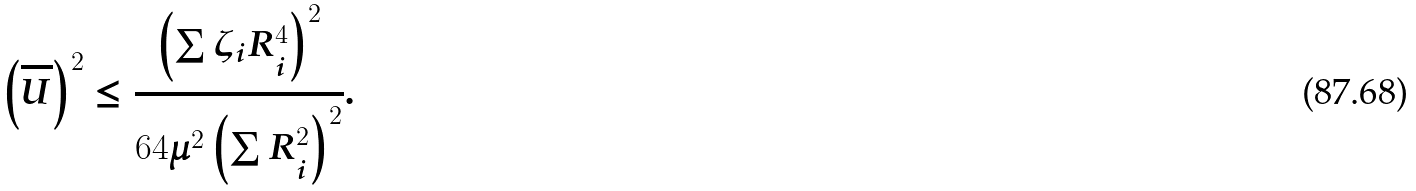Convert formula to latex. <formula><loc_0><loc_0><loc_500><loc_500>\left ( \overline { U } \right ) ^ { 2 } \leq \frac { \left ( \sum \zeta _ { i } R _ { i } ^ { 4 } \right ) ^ { 2 } } { 6 4 \mu ^ { 2 } \left ( \sum R _ { i } ^ { 2 } \right ) ^ { 2 } } .</formula> 